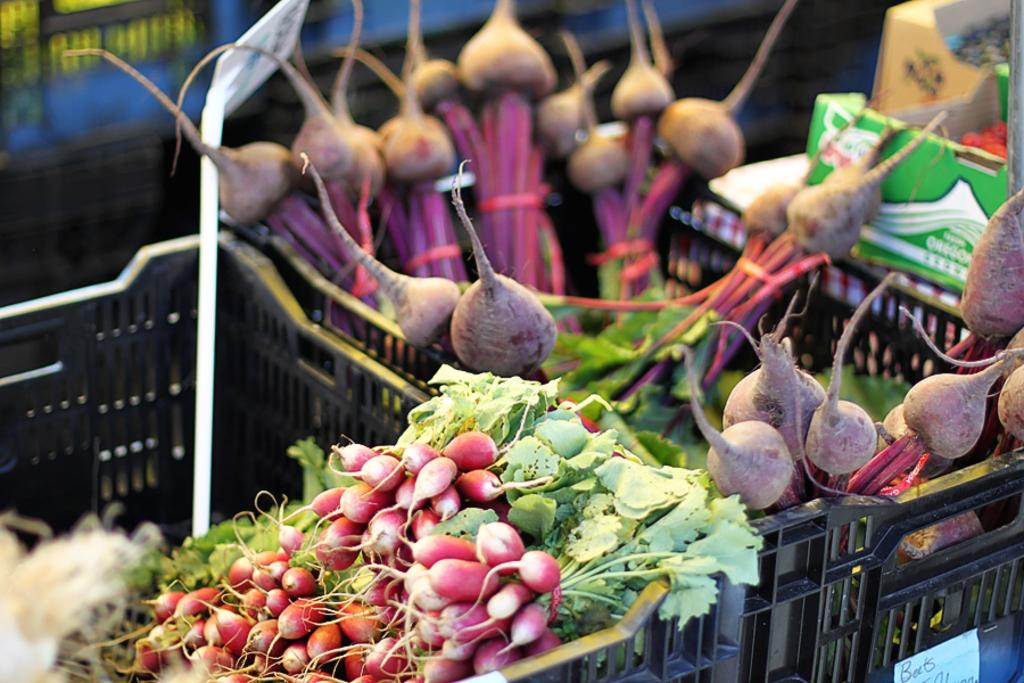What type of food can be seen in the front of the image? There are vegetables in the front of the image. Can you describe the background of the image? The background of the image is blurry. How many beds are visible in the image? There are no beds present in the image; it features vegetables in the front and a blurry background. 